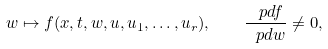Convert formula to latex. <formula><loc_0><loc_0><loc_500><loc_500>w \mapsto f ( x , t , w , u , u _ { 1 } , \dots , u _ { r } ) , \quad \frac { \ p d f } { \ p d w } \neq 0 ,</formula> 